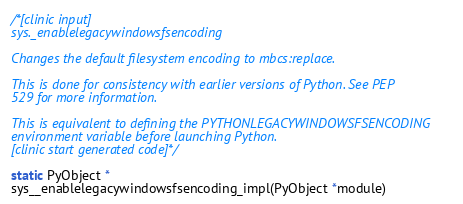<code> <loc_0><loc_0><loc_500><loc_500><_C_>
/*[clinic input]
sys._enablelegacywindowsfsencoding

Changes the default filesystem encoding to mbcs:replace.

This is done for consistency with earlier versions of Python. See PEP
529 for more information.

This is equivalent to defining the PYTHONLEGACYWINDOWSFSENCODING
environment variable before launching Python.
[clinic start generated code]*/

static PyObject *
sys__enablelegacywindowsfsencoding_impl(PyObject *module)</code> 